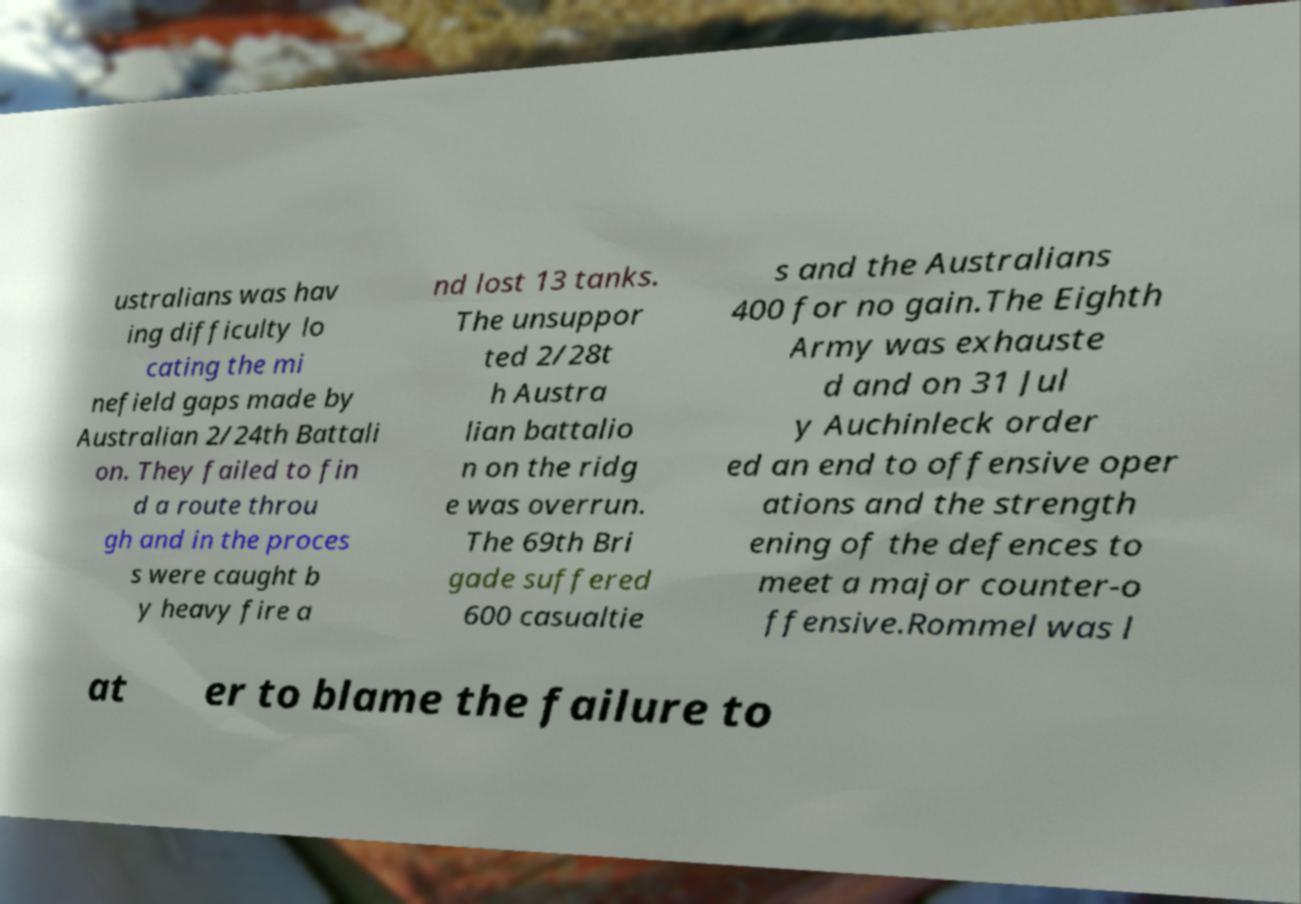For documentation purposes, I need the text within this image transcribed. Could you provide that? ustralians was hav ing difficulty lo cating the mi nefield gaps made by Australian 2/24th Battali on. They failed to fin d a route throu gh and in the proces s were caught b y heavy fire a nd lost 13 tanks. The unsuppor ted 2/28t h Austra lian battalio n on the ridg e was overrun. The 69th Bri gade suffered 600 casualtie s and the Australians 400 for no gain.The Eighth Army was exhauste d and on 31 Jul y Auchinleck order ed an end to offensive oper ations and the strength ening of the defences to meet a major counter-o ffensive.Rommel was l at er to blame the failure to 